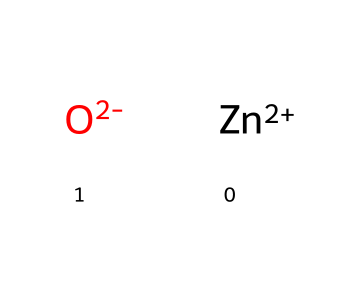What is the central metal in zinc white? The chemical structure shows the presence of zinc as the central metal atom, identified by its symbol "Zn" in the SMILES representation.
Answer: zinc How many oxygen atoms are present in zinc white? Analyzing the SMILES, there are two oxygen atoms represented by "O" in the structure; thus, the count is two.
Answer: two What is the charge on zinc in this compound? The SMILES notation shows "[Zn+2]", indicating that zinc has a charge of +2 in this compound.
Answer: +2 What type of bonds are present in this compound? The compound has ionic interactions represented by the charges on zinc (+2) and oxygen (-2), which indicates ionic bonds rather than covalent ones.
Answer: ionic Is zinc white an organometallic compound? The presence of zinc, a metal, directly bonded to carbon-containing compounds generally categorizes it as an organometallic compound; however, this particular structure does not show carbon. Thus, while it involves a metal, its classification can depend on broader definitions. Nevertheless, due to its use in artistic materials, it aligns with the characteristics of organometallics.
Answer: yes What is the overall charge of zinc white? The overall charge can be calculated by summing the charges on the components in the structure: +2 from zinc and -2 from the two oxygen atoms, leading to a neutral overall charge.
Answer: zero 